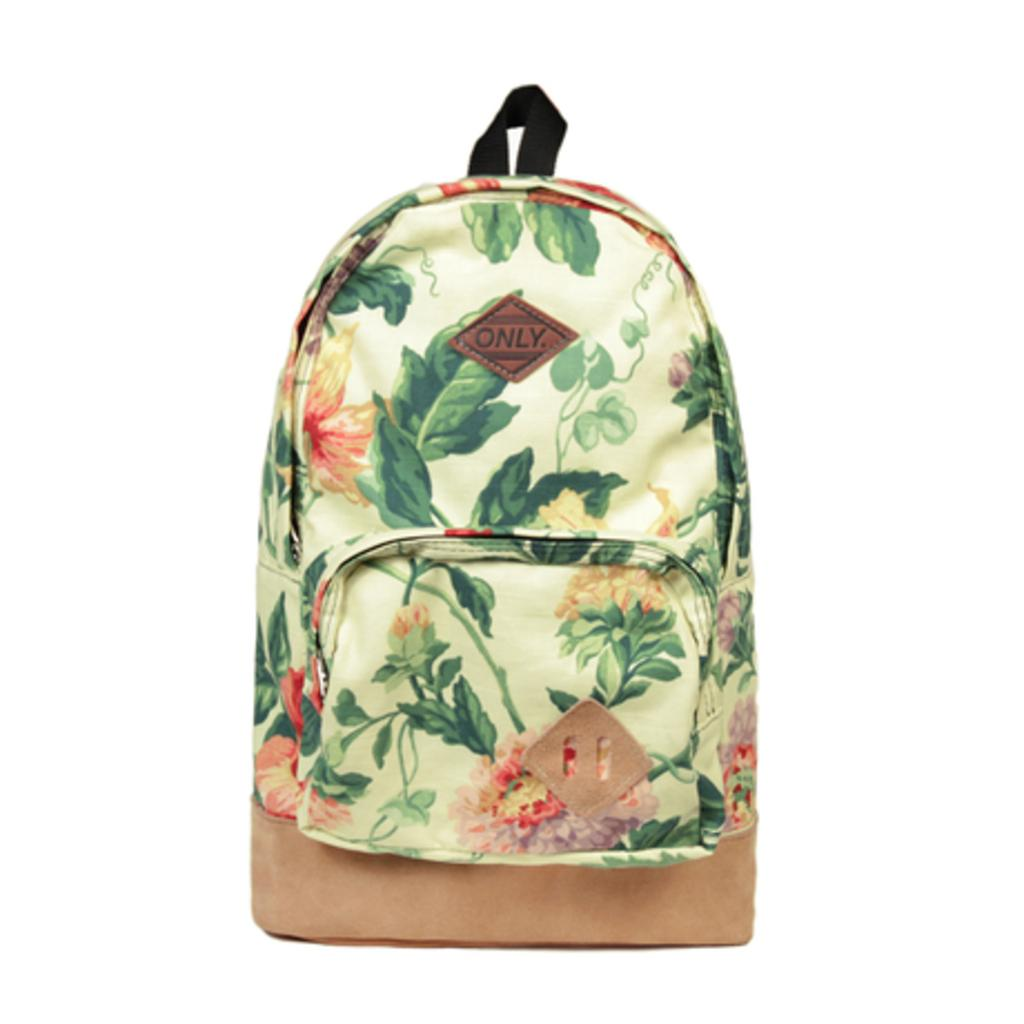<image>
Share a concise interpretation of the image provided. A backpack has an Only brand tag on it. 